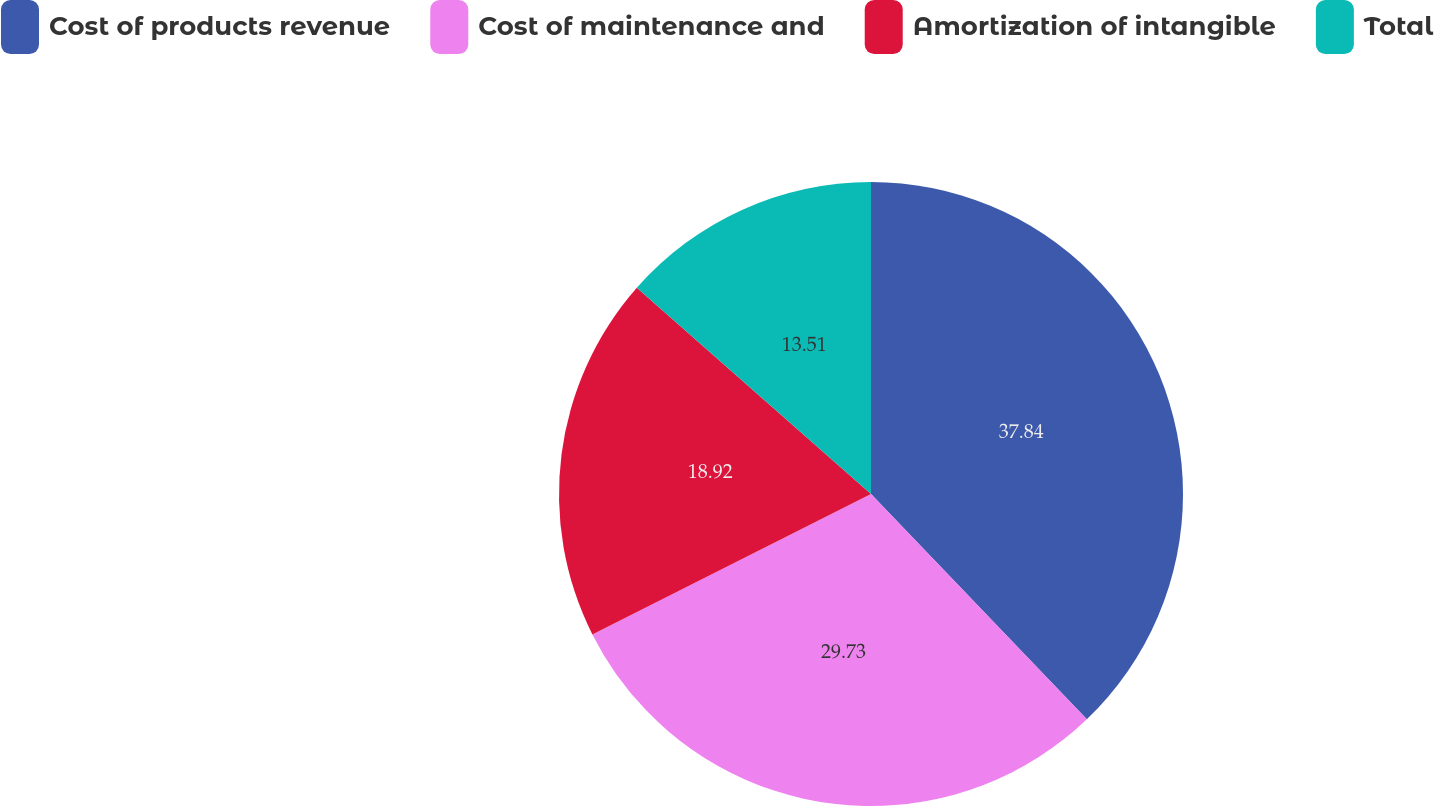<chart> <loc_0><loc_0><loc_500><loc_500><pie_chart><fcel>Cost of products revenue<fcel>Cost of maintenance and<fcel>Amortization of intangible<fcel>Total<nl><fcel>37.84%<fcel>29.73%<fcel>18.92%<fcel>13.51%<nl></chart> 